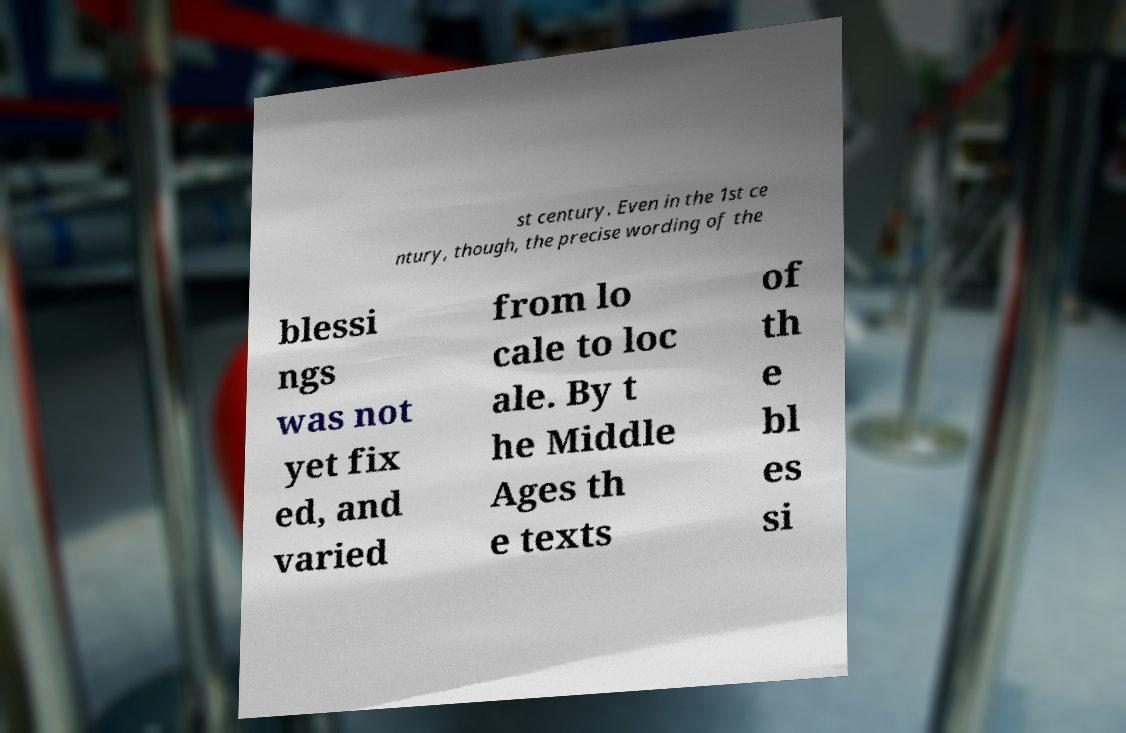I need the written content from this picture converted into text. Can you do that? st century. Even in the 1st ce ntury, though, the precise wording of the blessi ngs was not yet fix ed, and varied from lo cale to loc ale. By t he Middle Ages th e texts of th e bl es si 